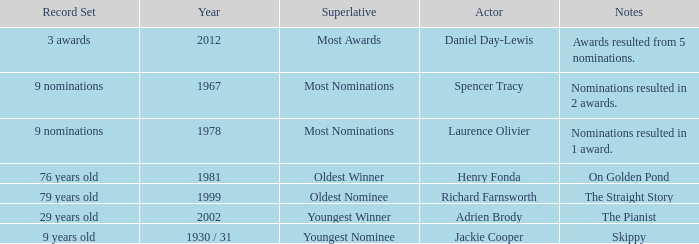What year was the the youngest nominee a winner? 1930 / 31. 